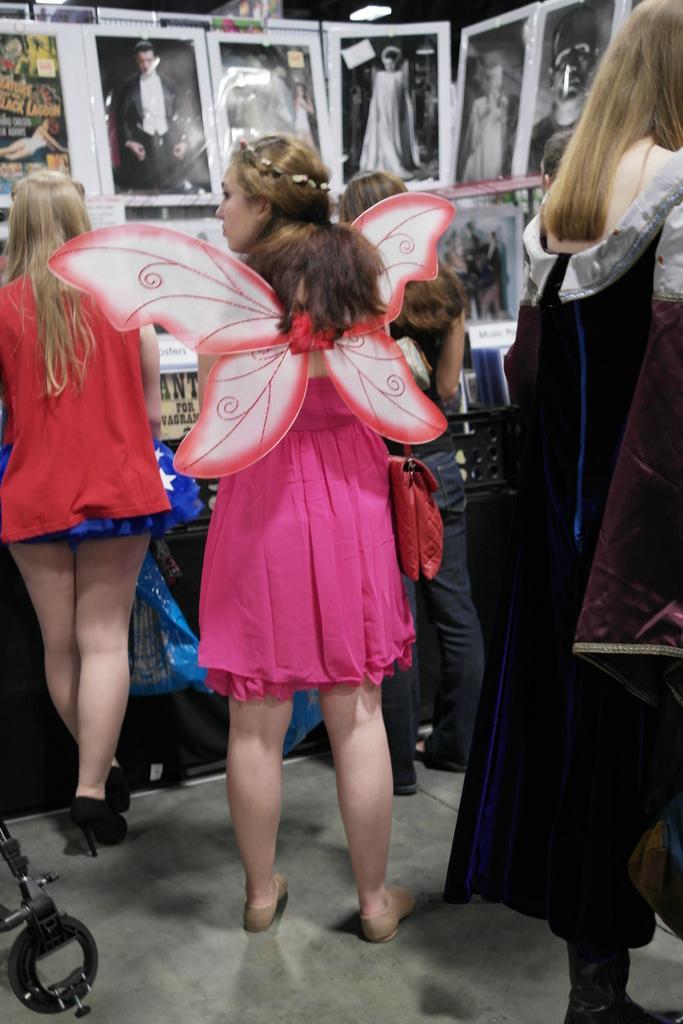Can you describe this image briefly? In this image I can see a crowd on the floor. On the top I can see photo frames. This image is taken may be in a room. 